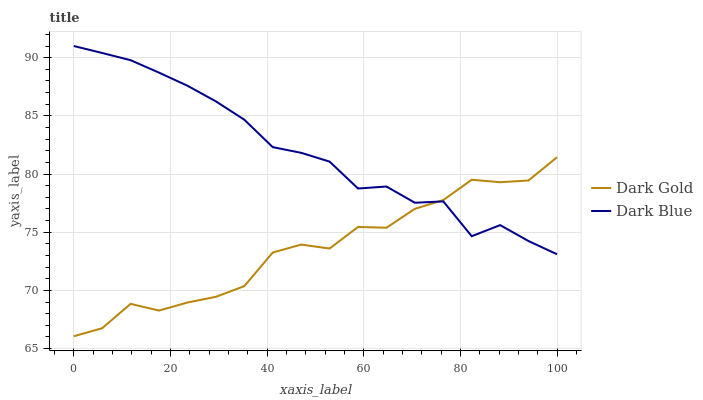Does Dark Gold have the minimum area under the curve?
Answer yes or no. Yes. Does Dark Blue have the maximum area under the curve?
Answer yes or no. Yes. Does Dark Gold have the maximum area under the curve?
Answer yes or no. No. Is Dark Blue the smoothest?
Answer yes or no. Yes. Is Dark Gold the roughest?
Answer yes or no. Yes. Is Dark Gold the smoothest?
Answer yes or no. No. Does Dark Blue have the highest value?
Answer yes or no. Yes. Does Dark Gold have the highest value?
Answer yes or no. No. Does Dark Gold intersect Dark Blue?
Answer yes or no. Yes. Is Dark Gold less than Dark Blue?
Answer yes or no. No. Is Dark Gold greater than Dark Blue?
Answer yes or no. No. 